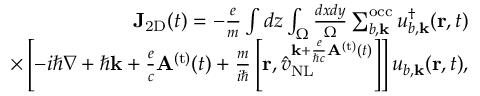Convert formula to latex. <formula><loc_0><loc_0><loc_500><loc_500>\begin{array} { r } { { J } _ { 2 D } ( t ) = - \frac { e } { m } \int d z \int _ { \Omega } \frac { d x d y } { \Omega } \sum _ { b , { k } } ^ { o c c } u _ { b , { k } } ^ { \dagger } ( { r } , t ) } \\ { \times \left [ - i \hbar { \nabla } + \hbar { k } + \frac { e } { c } { A } ^ { ( t ) } ( t ) + \frac { m } { i } \left [ { r } , \hat { v } _ { N L } ^ { { { k } + \frac { e } { \hbar { c } } { A } ^ { ( t ) } ( t ) } } \right ] \right ] u _ { b , { k } } ( { r } , t ) , } \end{array}</formula> 